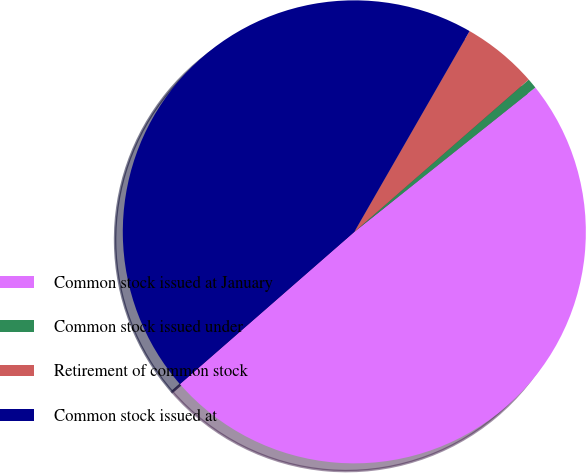<chart> <loc_0><loc_0><loc_500><loc_500><pie_chart><fcel>Common stock issued at January<fcel>Common stock issued under<fcel>Retirement of common stock<fcel>Common stock issued at<nl><fcel>49.29%<fcel>0.71%<fcel>5.28%<fcel>44.72%<nl></chart> 